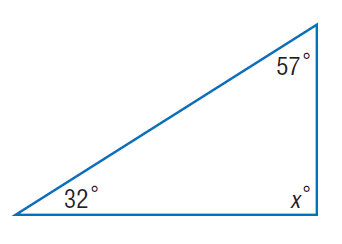Answer the mathemtical geometry problem and directly provide the correct option letter.
Question: Find x.
Choices: A: 32 B: 57 C: 58 D: 91 D 